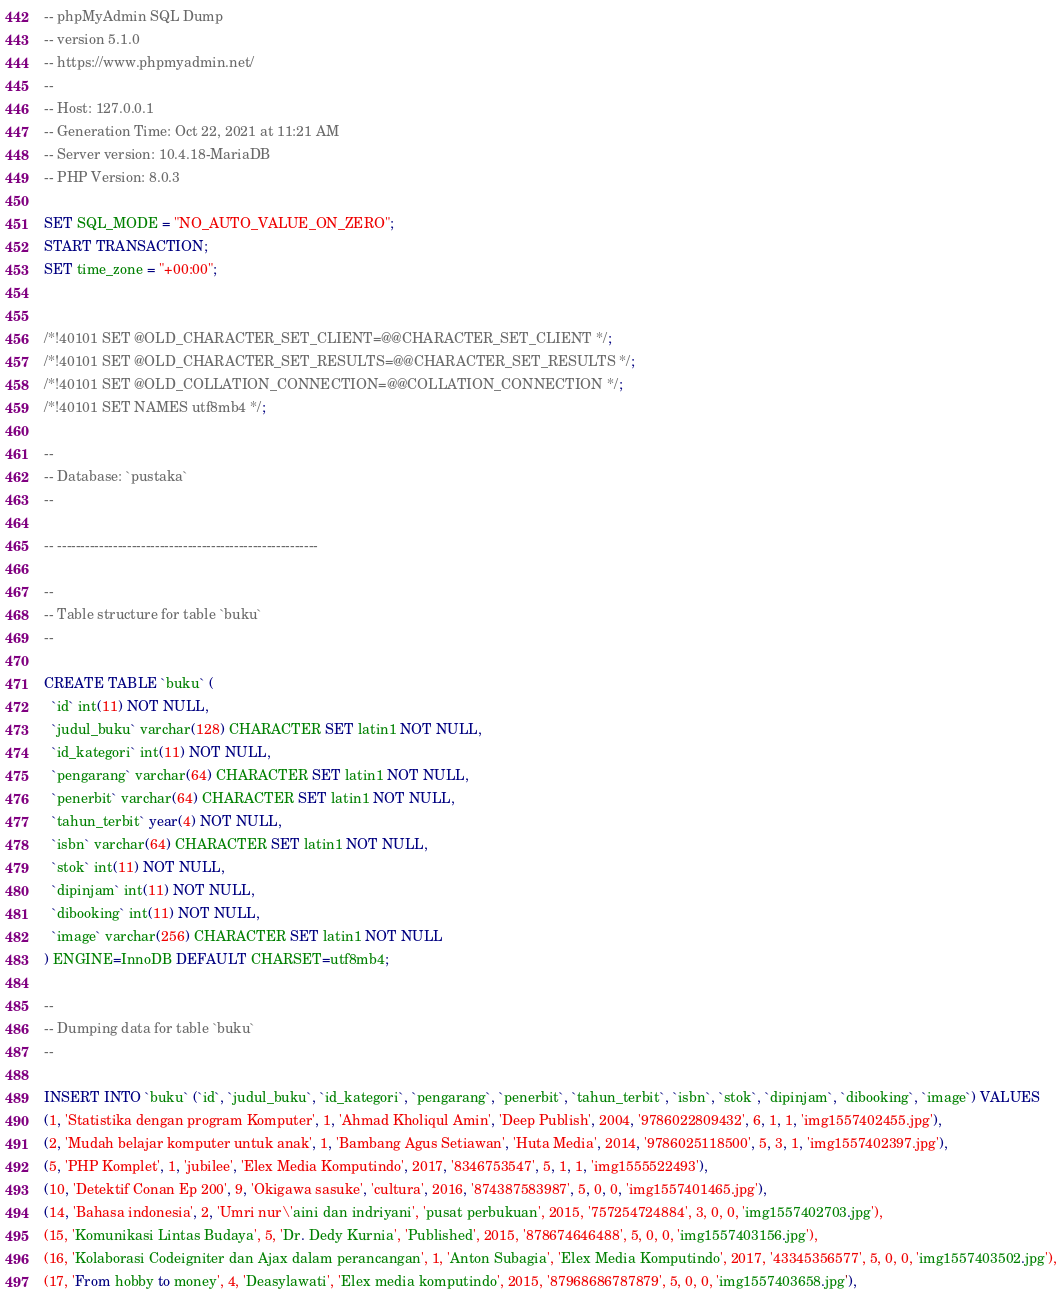Convert code to text. <code><loc_0><loc_0><loc_500><loc_500><_SQL_>-- phpMyAdmin SQL Dump
-- version 5.1.0
-- https://www.phpmyadmin.net/
--
-- Host: 127.0.0.1
-- Generation Time: Oct 22, 2021 at 11:21 AM
-- Server version: 10.4.18-MariaDB
-- PHP Version: 8.0.3

SET SQL_MODE = "NO_AUTO_VALUE_ON_ZERO";
START TRANSACTION;
SET time_zone = "+00:00";


/*!40101 SET @OLD_CHARACTER_SET_CLIENT=@@CHARACTER_SET_CLIENT */;
/*!40101 SET @OLD_CHARACTER_SET_RESULTS=@@CHARACTER_SET_RESULTS */;
/*!40101 SET @OLD_COLLATION_CONNECTION=@@COLLATION_CONNECTION */;
/*!40101 SET NAMES utf8mb4 */;

--
-- Database: `pustaka`
--

-- --------------------------------------------------------

--
-- Table structure for table `buku`
--

CREATE TABLE `buku` (
  `id` int(11) NOT NULL,
  `judul_buku` varchar(128) CHARACTER SET latin1 NOT NULL,
  `id_kategori` int(11) NOT NULL,
  `pengarang` varchar(64) CHARACTER SET latin1 NOT NULL,
  `penerbit` varchar(64) CHARACTER SET latin1 NOT NULL,
  `tahun_terbit` year(4) NOT NULL,
  `isbn` varchar(64) CHARACTER SET latin1 NOT NULL,
  `stok` int(11) NOT NULL,
  `dipinjam` int(11) NOT NULL,
  `dibooking` int(11) NOT NULL,
  `image` varchar(256) CHARACTER SET latin1 NOT NULL
) ENGINE=InnoDB DEFAULT CHARSET=utf8mb4;

--
-- Dumping data for table `buku`
--

INSERT INTO `buku` (`id`, `judul_buku`, `id_kategori`, `pengarang`, `penerbit`, `tahun_terbit`, `isbn`, `stok`, `dipinjam`, `dibooking`, `image`) VALUES
(1, 'Statistika dengan program Komputer', 1, 'Ahmad Kholiqul Amin', 'Deep Publish', 2004, '9786022809432', 6, 1, 1, 'img1557402455.jpg'),
(2, 'Mudah belajar komputer untuk anak', 1, 'Bambang Agus Setiawan', 'Huta Media', 2014, '9786025118500', 5, 3, 1, 'img1557402397.jpg'),
(5, 'PHP Komplet', 1, 'jubilee', 'Elex Media Komputindo', 2017, '8346753547', 5, 1, 1, 'img1555522493'),
(10, 'Detektif Conan Ep 200', 9, 'Okigawa sasuke', 'cultura', 2016, '874387583987', 5, 0, 0, 'img1557401465.jpg'),
(14, 'Bahasa indonesia', 2, 'Umri nur\'aini dan indriyani', 'pusat perbukuan', 2015, '757254724884', 3, 0, 0, 'img1557402703.jpg'),
(15, 'Komunikasi Lintas Budaya', 5, 'Dr. Dedy Kurnia', 'Published', 2015, '878674646488', 5, 0, 0, 'img1557403156.jpg'),
(16, 'Kolaborasi Codeigniter dan Ajax dalam perancangan', 1, 'Anton Subagia', 'Elex Media Komputindo', 2017, '43345356577', 5, 0, 0, 'img1557403502.jpg'),
(17, 'From hobby to money', 4, 'Deasylawati', 'Elex media komputindo', 2015, '87968686787879', 5, 0, 0, 'img1557403658.jpg'),</code> 